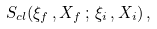Convert formula to latex. <formula><loc_0><loc_0><loc_500><loc_500>\, S _ { c l } ( \xi _ { f } \, , X _ { f } \, ; \, \xi _ { i } \, , X _ { i } ) \, , \,</formula> 